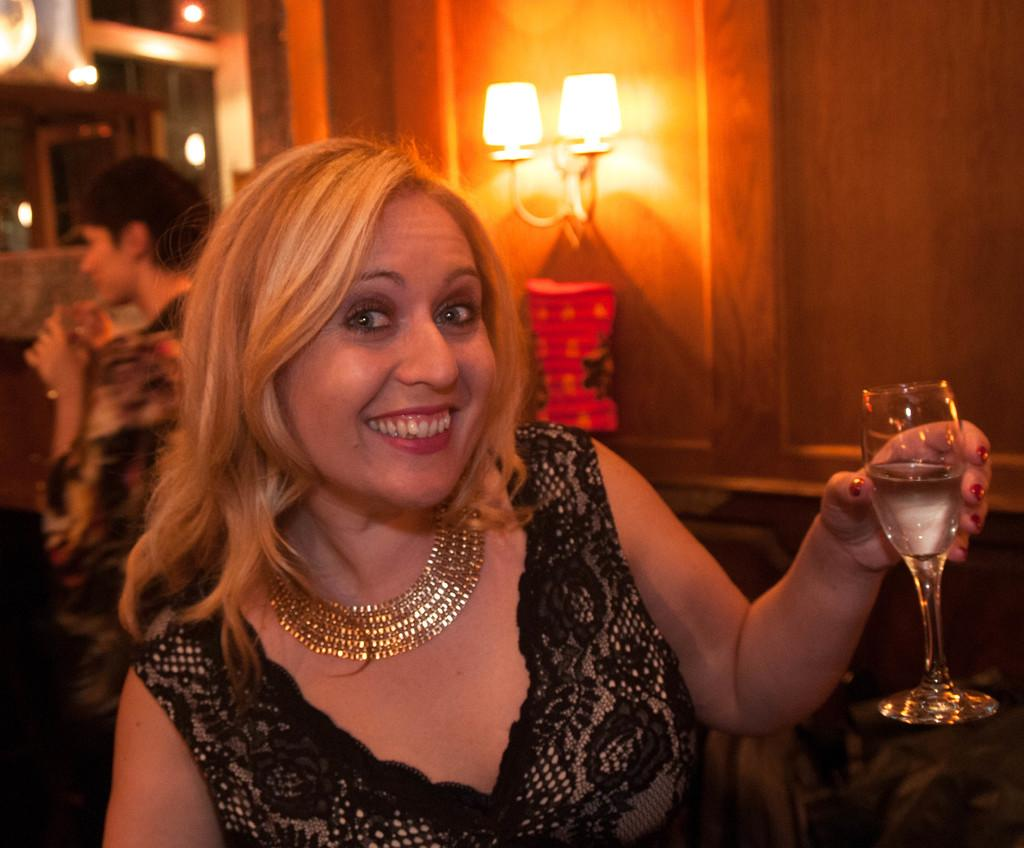Who is the main subject in the image? There is a woman in the image. What is the woman doing in the image? The woman is sitting. What object is the woman holding in her hand? The woman is holding a wine glass in her hand. What type of pie is being served on the table in the image? There is no table or pie present in the image; it only features a woman sitting and holding a wine glass. 